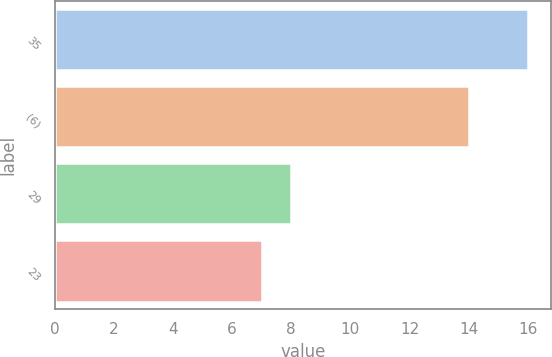Convert chart to OTSL. <chart><loc_0><loc_0><loc_500><loc_500><bar_chart><fcel>35<fcel>(6)<fcel>29<fcel>23<nl><fcel>16<fcel>14<fcel>8<fcel>7<nl></chart> 